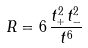<formula> <loc_0><loc_0><loc_500><loc_500>R = 6 \, \frac { t _ { + } ^ { 2 } t _ { - } ^ { 2 } } { t ^ { 6 } } \</formula> 